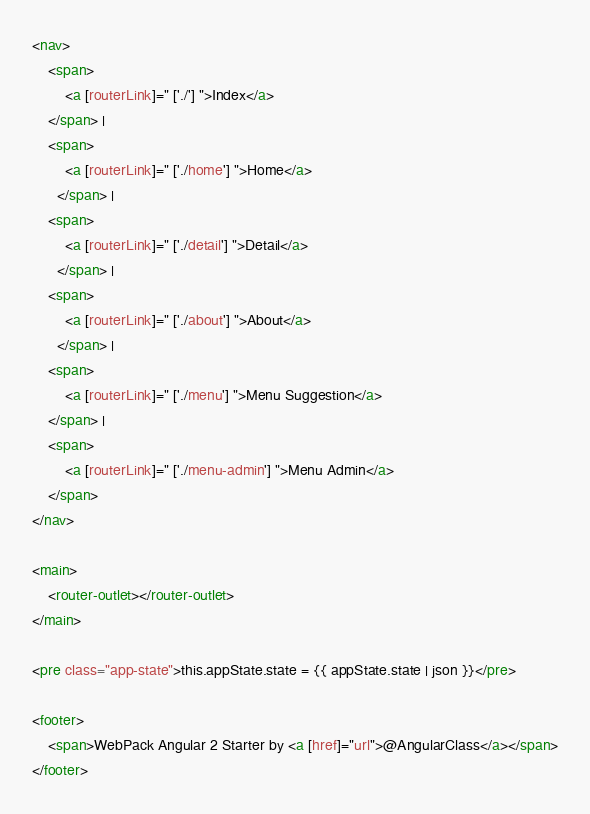Convert code to text. <code><loc_0><loc_0><loc_500><loc_500><_HTML_><nav>
	<span>
        <a [routerLink]=" ['./'] ">Index</a>
    </span> |
	<span>
        <a [routerLink]=" ['./home'] ">Home</a>
      </span> |
	<span>
        <a [routerLink]=" ['./detail'] ">Detail</a>
      </span> |
	<span>
        <a [routerLink]=" ['./about'] ">About</a>
      </span> |
    <span>
        <a [routerLink]=" ['./menu'] ">Menu Suggestion</a>
    </span> |
    <span>
        <a [routerLink]=" ['./menu-admin'] ">Menu Admin</a>
    </span>
</nav>

<main>
	<router-outlet></router-outlet>
</main>

<pre class="app-state">this.appState.state = {{ appState.state | json }}</pre>

<footer>
	<span>WebPack Angular 2 Starter by <a [href]="url">@AngularClass</a></span>
</footer></code> 